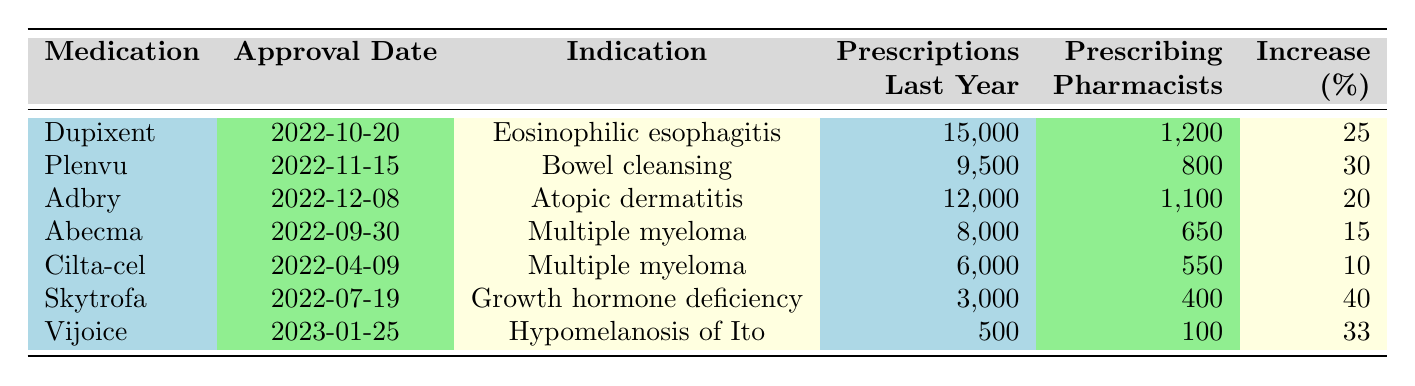What medication had the highest number of prescriptions last year? By examining the “Prescriptions Last Year” column, Dupixent has the highest value at 15,000 prescriptions.
Answer: Dupixent Which medication had the lowest percentage increase in prescriptions? By looking at the “Increase (%)” column, Cilta-cel has the lowest percentage increase of 10%.
Answer: Cilta-cel How many medications were approved in 2022? Counting the entries from the table, there are 6 medications listed that were approved in 2022.
Answer: 6 What is the average number of prescriptions for medications that indicate treatment for multiple myeloma? Adding the prescriptions for Abecma (8,000) and Cilta-cel (6,000) yields 14,000. Dividing by 2 gives an average of 7,000.
Answer: 7,000 Did Vijoice have a higher number of prescriptions than Skytrofa? By comparing the “Prescriptions Last Year” values, Vijoice had 500 prescriptions while Skytrofa had 3,000, thus Skytrofa had more.
Answer: No What is the total number of prescriptions for all medications listed? By summing all prescriptions: 15,000 + 9,500 + 12,000 + 8,000 + 6,000 + 3,000 + 500 = 54,000.
Answer: 54,000 Which medication has the highest number of prescribing pharmacists? Reviewing the “Prescribing Pharmacists” column, Dupixent has the highest count with 1,200.
Answer: Dupixent What percentage increase does the medication with the earliest approval date have? The earliest approved medication is Cilta-cel, which has a percentage increase of 10%.
Answer: 10% How many more prescriptions did Skytrofa have compared to Cilta-cel? Skytrofa had 3,000 prescriptions, while Cilta-cel had 6,000, so they differ by 3,000 - 6,000 = -3,000 (indicating Cilta-cel had more).
Answer: Cilta-cel had 3,000 more prescriptions Which indication relates to the medication with the maximum percentage increase? Evaluating the “Percentage Increase” column, Skytrofa has the highest increase at 40%, which is for Growth hormone deficiency.
Answer: Growth hormone deficiency 